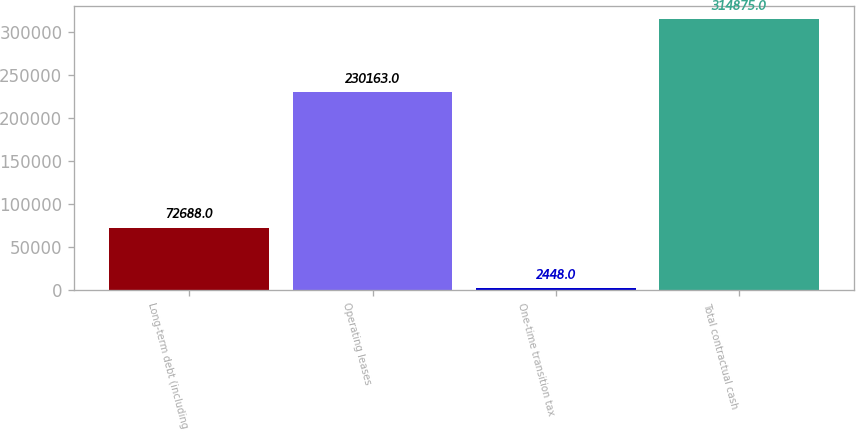<chart> <loc_0><loc_0><loc_500><loc_500><bar_chart><fcel>Long-term debt (including<fcel>Operating leases<fcel>One-time transition tax<fcel>Total contractual cash<nl><fcel>72688<fcel>230163<fcel>2448<fcel>314875<nl></chart> 